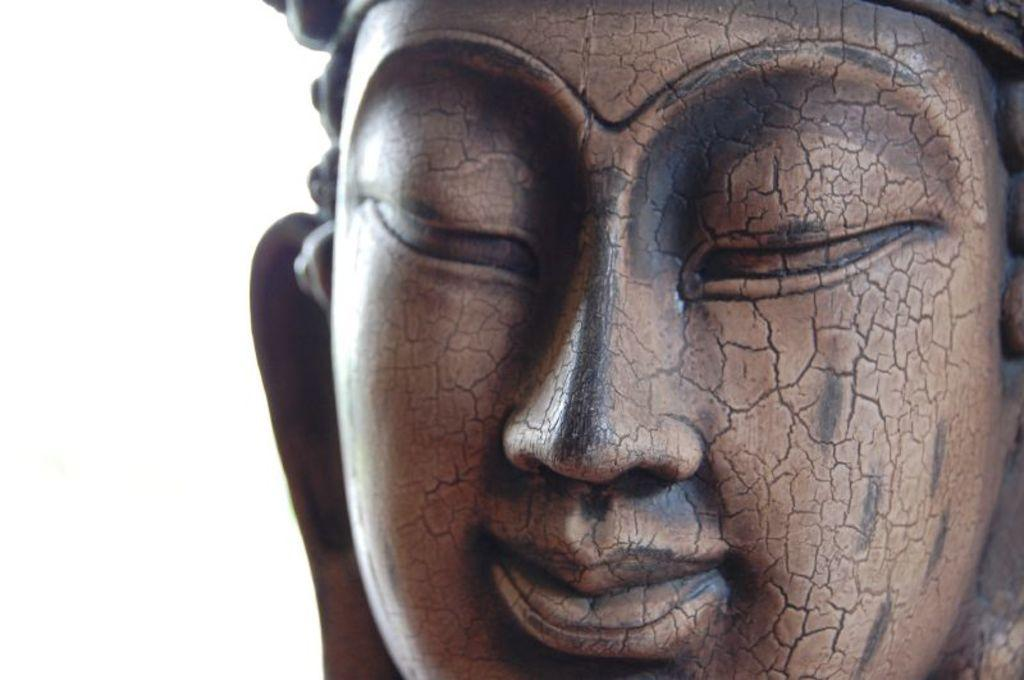What is the main subject of the picture? The main subject of the picture is a sculpture. Can you describe the background of the image? There is a white background on the left side of the image. What type of profit can be seen growing in the image? There is no mention of profit in the image, as it features a sculpture and a white background. Can you identify any achievers in the image? There is no indication of any achievers in the image, as it only shows a sculpture and a white background. 